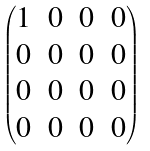Convert formula to latex. <formula><loc_0><loc_0><loc_500><loc_500>\begin{pmatrix} 1 & 0 & 0 & 0 \\ 0 & 0 & 0 & 0 \\ 0 & 0 & 0 & 0 \\ 0 & 0 & 0 & 0 \end{pmatrix}</formula> 